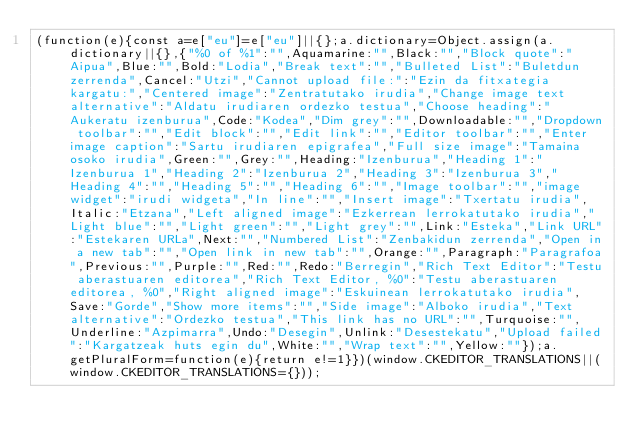Convert code to text. <code><loc_0><loc_0><loc_500><loc_500><_JavaScript_>(function(e){const a=e["eu"]=e["eu"]||{};a.dictionary=Object.assign(a.dictionary||{},{"%0 of %1":"",Aquamarine:"",Black:"","Block quote":"Aipua",Blue:"",Bold:"Lodia","Break text":"","Bulleted List":"Buletdun zerrenda",Cancel:"Utzi","Cannot upload file:":"Ezin da fitxategia kargatu:","Centered image":"Zentratutako irudia","Change image text alternative":"Aldatu irudiaren ordezko testua","Choose heading":"Aukeratu izenburua",Code:"Kodea","Dim grey":"",Downloadable:"","Dropdown toolbar":"","Edit block":"","Edit link":"","Editor toolbar":"","Enter image caption":"Sartu irudiaren epigrafea","Full size image":"Tamaina osoko irudia",Green:"",Grey:"",Heading:"Izenburua","Heading 1":"Izenburua 1","Heading 2":"Izenburua 2","Heading 3":"Izenburua 3","Heading 4":"","Heading 5":"","Heading 6":"","Image toolbar":"","image widget":"irudi widgeta","In line":"","Insert image":"Txertatu irudia",Italic:"Etzana","Left aligned image":"Ezkerrean lerrokatutako irudia","Light blue":"","Light green":"","Light grey":"",Link:"Esteka","Link URL":"Estekaren URLa",Next:"","Numbered List":"Zenbakidun zerrenda","Open in a new tab":"","Open link in new tab":"",Orange:"",Paragraph:"Paragrafoa",Previous:"",Purple:"",Red:"",Redo:"Berregin","Rich Text Editor":"Testu aberastuaren editorea","Rich Text Editor, %0":"Testu aberastuaren editorea, %0","Right aligned image":"Eskuinean lerrokatutako irudia",Save:"Gorde","Show more items":"","Side image":"Alboko irudia","Text alternative":"Ordezko testua","This link has no URL":"",Turquoise:"",Underline:"Azpimarra",Undo:"Desegin",Unlink:"Desestekatu","Upload failed":"Kargatzeak huts egin du",White:"","Wrap text":"",Yellow:""});a.getPluralForm=function(e){return e!=1}})(window.CKEDITOR_TRANSLATIONS||(window.CKEDITOR_TRANSLATIONS={}));</code> 